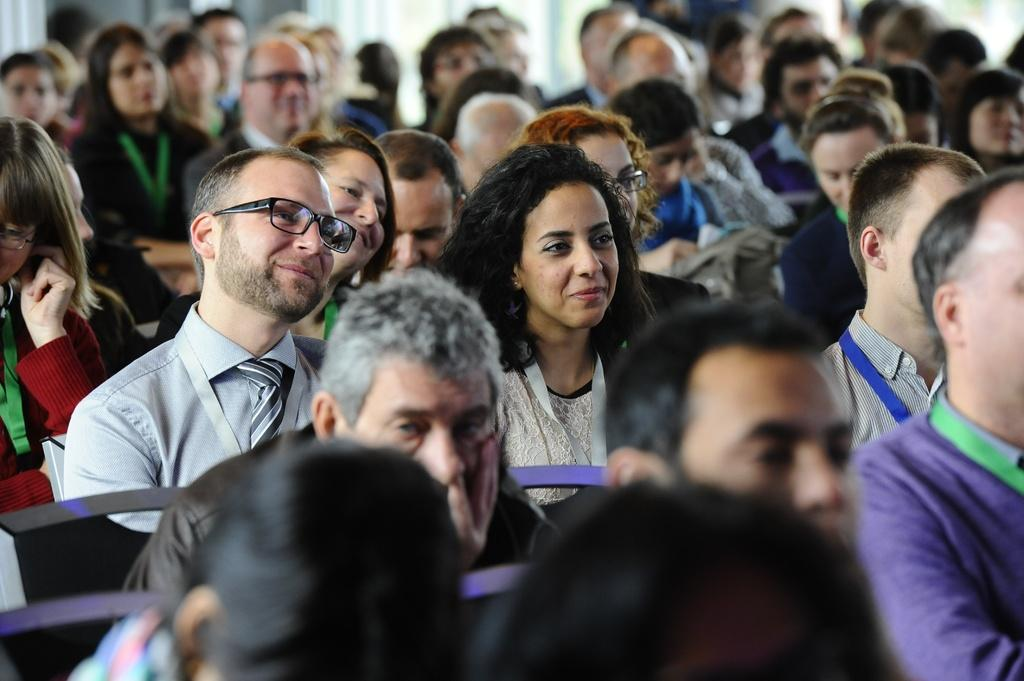What are the people in the image doing? The people in the image are sitting. Can you describe any accessories that some of the people are wearing? Some of the people are wearing glasses. How would you describe the background of the image? The background of the image is slightly blurry. What type of kettle can be seen in the image? There is no kettle present in the image. Can you describe the carriage that the people are riding in the image? There is no carriage present in the image; the people are sitting. 